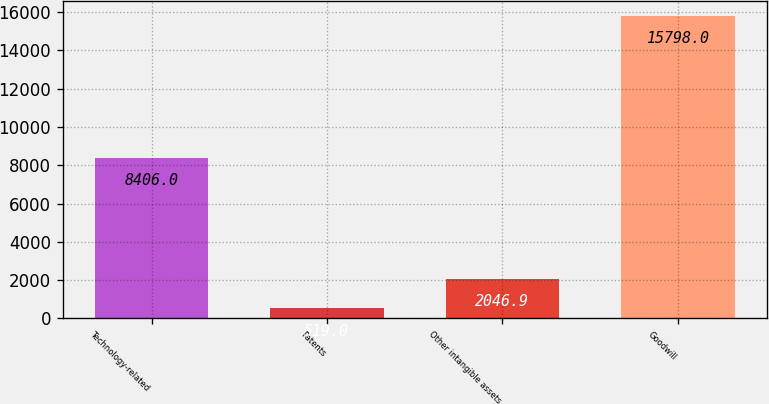Convert chart to OTSL. <chart><loc_0><loc_0><loc_500><loc_500><bar_chart><fcel>Technology-related<fcel>Patents<fcel>Other intangible assets<fcel>Goodwill<nl><fcel>8406<fcel>519<fcel>2046.9<fcel>15798<nl></chart> 